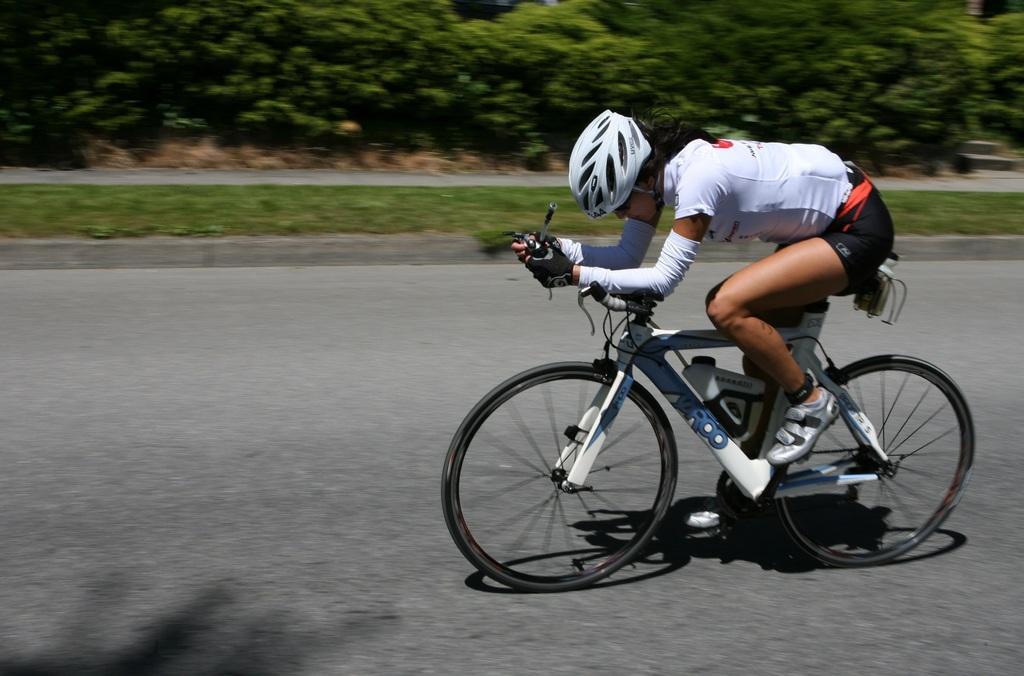Could you give a brief overview of what you see in this image? In this picture there is a girl on the right side of the image, she is cycling and there is greenery in the background area of the image. 